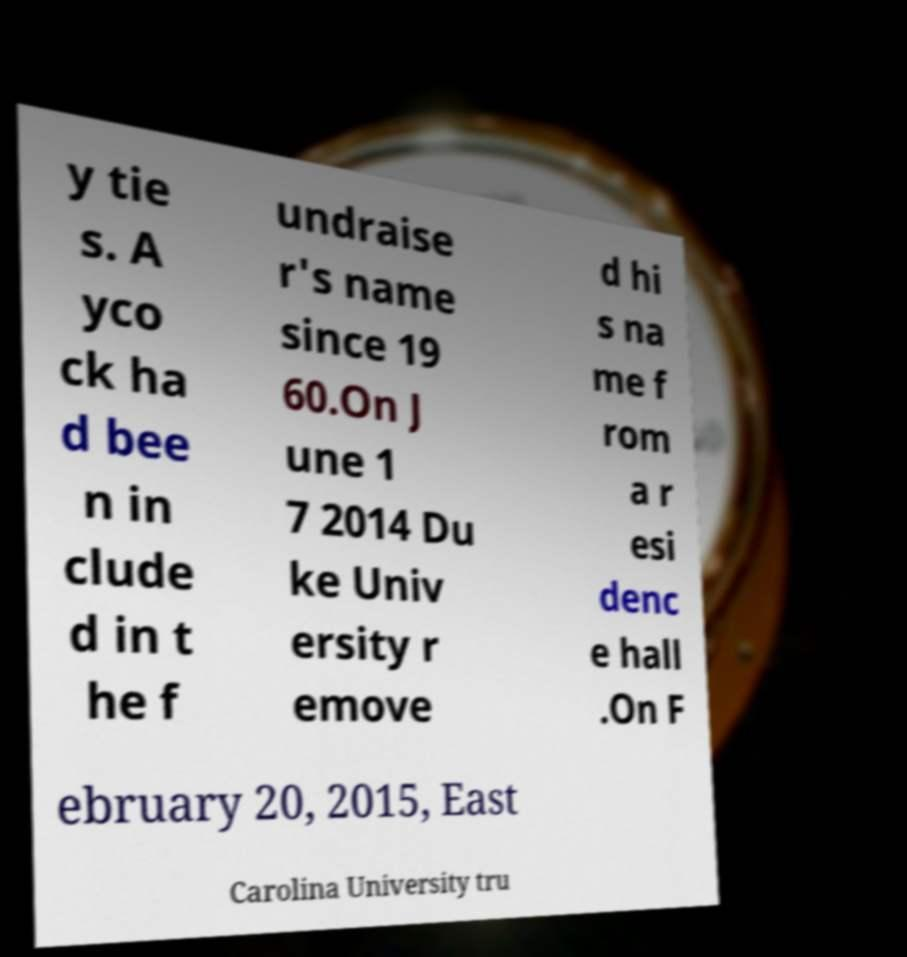There's text embedded in this image that I need extracted. Can you transcribe it verbatim? y tie s. A yco ck ha d bee n in clude d in t he f undraise r's name since 19 60.On J une 1 7 2014 Du ke Univ ersity r emove d hi s na me f rom a r esi denc e hall .On F ebruary 20, 2015, East Carolina University tru 